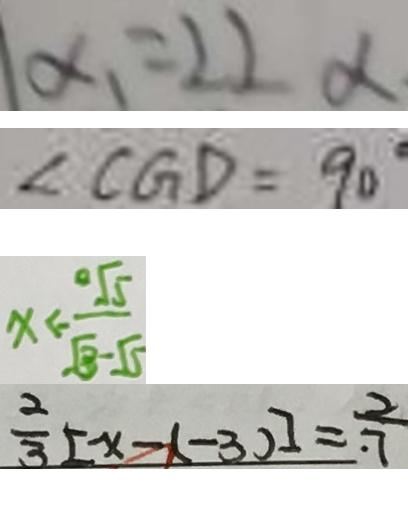Convert formula to latex. <formula><loc_0><loc_0><loc_500><loc_500>\alpha _ { 1 } = 2 2 _ { \alpha } 
 \angle C G D = 9 0 ^ { \circ } 
 x < - \frac { \sqrt { 5 } } { \sqrt { 3 } - 5 } 
 \frac { 2 } { 3 } [ x - ( - 3 ) ] = \frac { 2 } { 7 }</formula> 